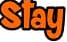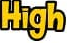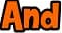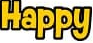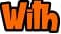Read the text from these images in sequence, separated by a semicolon. Stay; High; And; Happy; With 